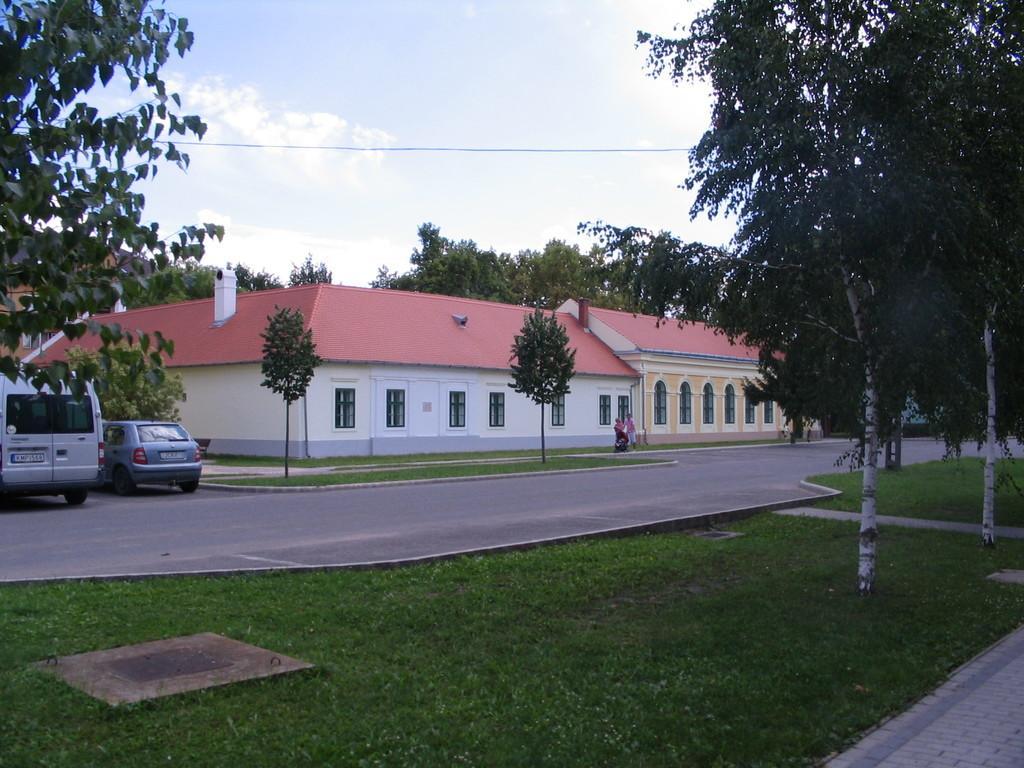Could you give a brief overview of what you see in this image? In the center of the image we can see the buildings, windows, roofs and two people are walking and holding a baby trolley. In the background of the image we can see the trees, grass, road. On the left side of the image we can see two vehicles. At the bottom of the image we can see the ground and pavement. At the top of the image we can see the clouds in the sky and wire. 